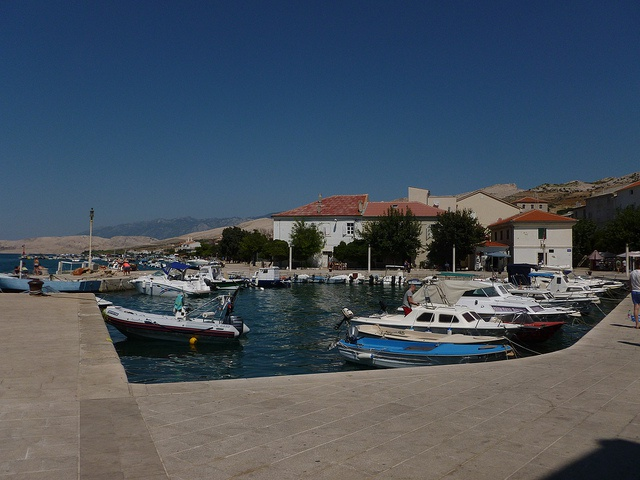Describe the objects in this image and their specific colors. I can see boat in navy, black, darkgray, gray, and lightgray tones, boat in navy, black, blue, and gray tones, boat in navy, darkgray, black, gray, and lightgray tones, boat in navy, black, darkgray, gray, and maroon tones, and boat in navy, gray, and black tones in this image. 